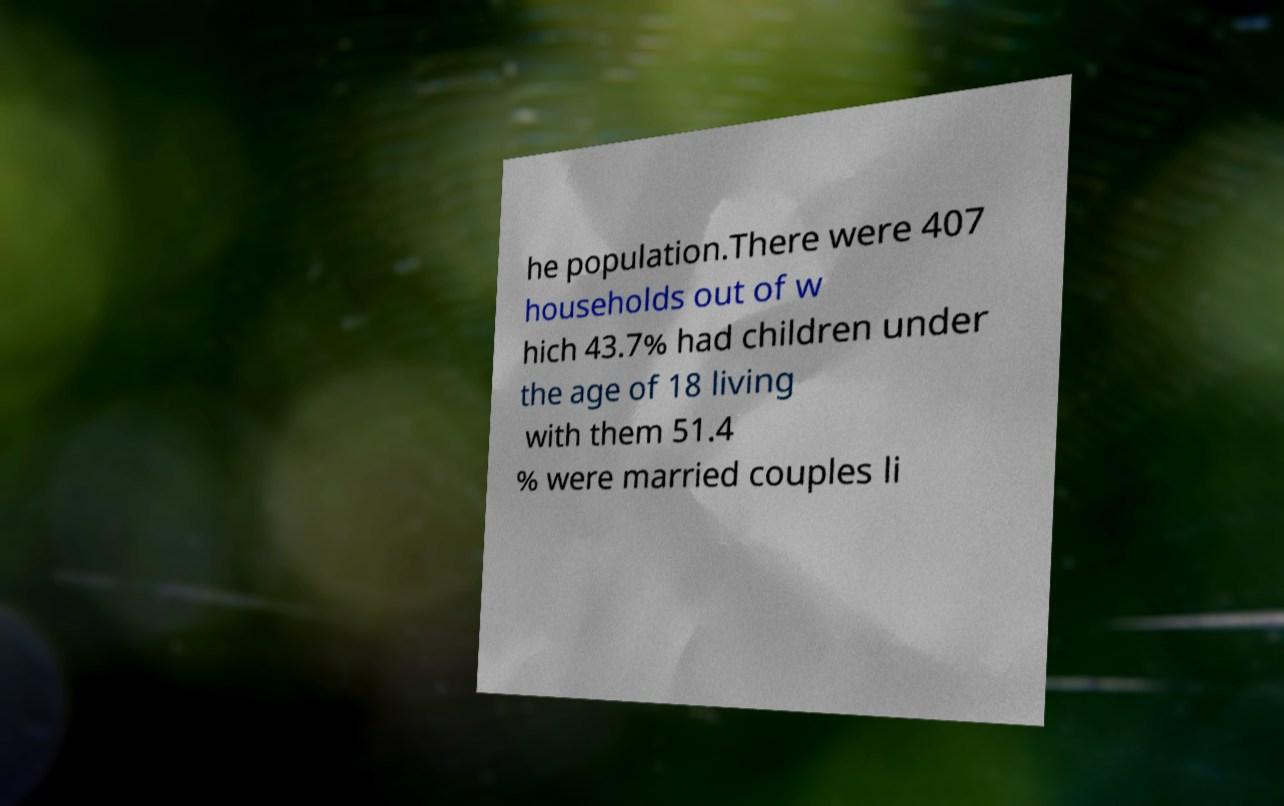Please identify and transcribe the text found in this image. he population.There were 407 households out of w hich 43.7% had children under the age of 18 living with them 51.4 % were married couples li 